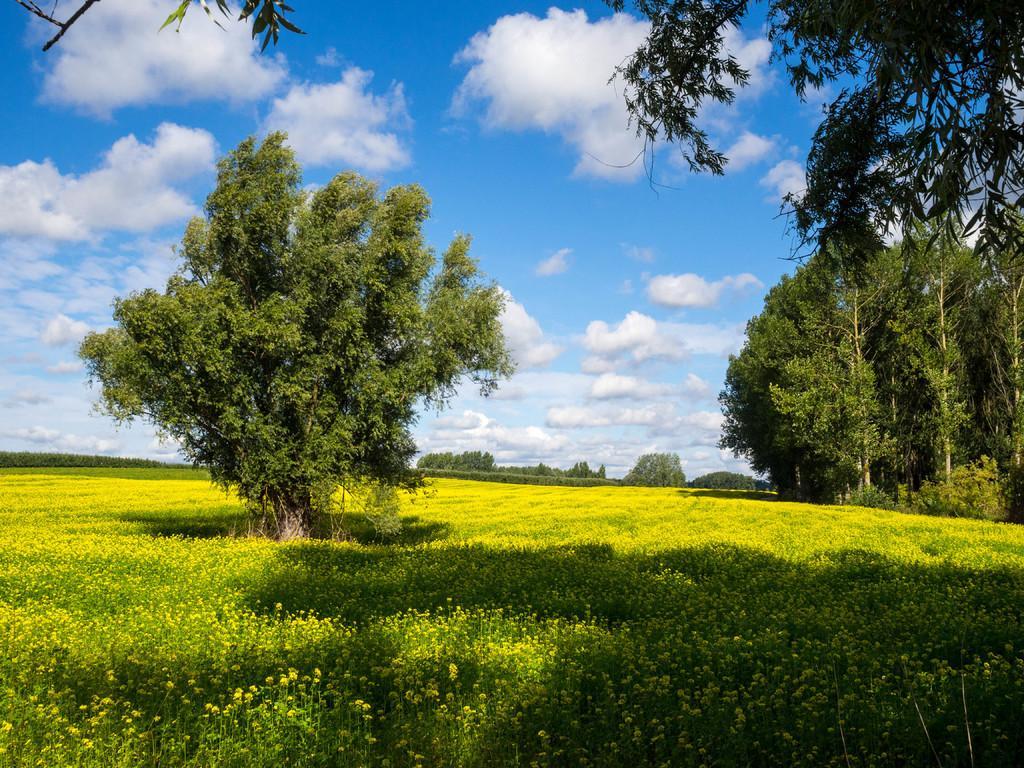Could you give a brief overview of what you see in this image? In this picture I can observe some plants on the ground. I can observe some trees. In the background there are some clouds in the sky. 